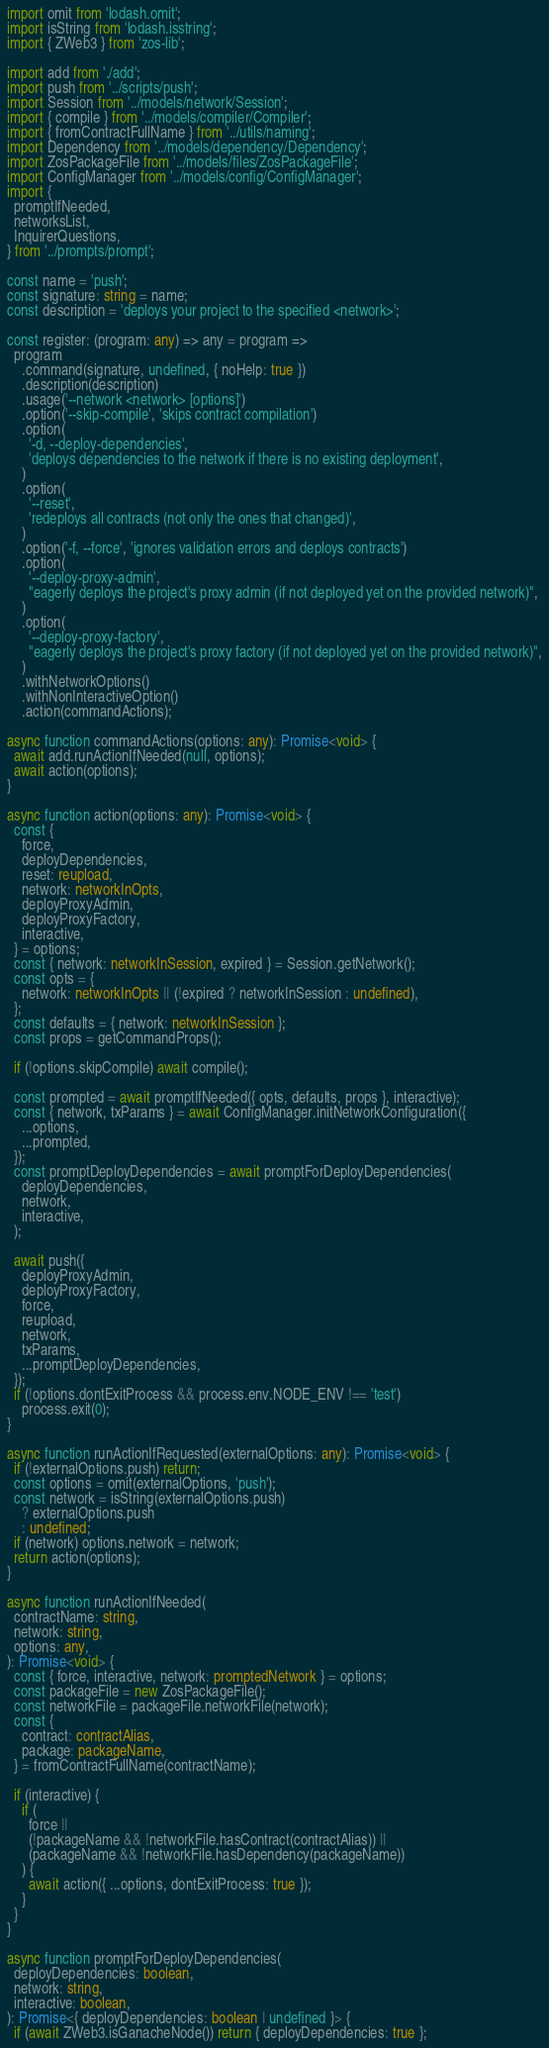Convert code to text. <code><loc_0><loc_0><loc_500><loc_500><_TypeScript_>import omit from 'lodash.omit';
import isString from 'lodash.isstring';
import { ZWeb3 } from 'zos-lib';

import add from './add';
import push from '../scripts/push';
import Session from '../models/network/Session';
import { compile } from '../models/compiler/Compiler';
import { fromContractFullName } from '../utils/naming';
import Dependency from '../models/dependency/Dependency';
import ZosPackageFile from '../models/files/ZosPackageFile';
import ConfigManager from '../models/config/ConfigManager';
import {
  promptIfNeeded,
  networksList,
  InquirerQuestions,
} from '../prompts/prompt';

const name = 'push';
const signature: string = name;
const description = 'deploys your project to the specified <network>';

const register: (program: any) => any = program =>
  program
    .command(signature, undefined, { noHelp: true })
    .description(description)
    .usage('--network <network> [options]')
    .option('--skip-compile', 'skips contract compilation')
    .option(
      '-d, --deploy-dependencies',
      'deploys dependencies to the network if there is no existing deployment',
    )
    .option(
      '--reset',
      'redeploys all contracts (not only the ones that changed)',
    )
    .option('-f, --force', 'ignores validation errors and deploys contracts')
    .option(
      '--deploy-proxy-admin',
      "eagerly deploys the project's proxy admin (if not deployed yet on the provided network)",
    )
    .option(
      '--deploy-proxy-factory',
      "eagerly deploys the project's proxy factory (if not deployed yet on the provided network)",
    )
    .withNetworkOptions()
    .withNonInteractiveOption()
    .action(commandActions);

async function commandActions(options: any): Promise<void> {
  await add.runActionIfNeeded(null, options);
  await action(options);
}

async function action(options: any): Promise<void> {
  const {
    force,
    deployDependencies,
    reset: reupload,
    network: networkInOpts,
    deployProxyAdmin,
    deployProxyFactory,
    interactive,
  } = options;
  const { network: networkInSession, expired } = Session.getNetwork();
  const opts = {
    network: networkInOpts || (!expired ? networkInSession : undefined),
  };
  const defaults = { network: networkInSession };
  const props = getCommandProps();

  if (!options.skipCompile) await compile();

  const prompted = await promptIfNeeded({ opts, defaults, props }, interactive);
  const { network, txParams } = await ConfigManager.initNetworkConfiguration({
    ...options,
    ...prompted,
  });
  const promptDeployDependencies = await promptForDeployDependencies(
    deployDependencies,
    network,
    interactive,
  );

  await push({
    deployProxyAdmin,
    deployProxyFactory,
    force,
    reupload,
    network,
    txParams,
    ...promptDeployDependencies,
  });
  if (!options.dontExitProcess && process.env.NODE_ENV !== 'test')
    process.exit(0);
}

async function runActionIfRequested(externalOptions: any): Promise<void> {
  if (!externalOptions.push) return;
  const options = omit(externalOptions, 'push');
  const network = isString(externalOptions.push)
    ? externalOptions.push
    : undefined;
  if (network) options.network = network;
  return action(options);
}

async function runActionIfNeeded(
  contractName: string,
  network: string,
  options: any,
): Promise<void> {
  const { force, interactive, network: promptedNetwork } = options;
  const packageFile = new ZosPackageFile();
  const networkFile = packageFile.networkFile(network);
  const {
    contract: contractAlias,
    package: packageName,
  } = fromContractFullName(contractName);

  if (interactive) {
    if (
      force ||
      (!packageName && !networkFile.hasContract(contractAlias)) ||
      (packageName && !networkFile.hasDependency(packageName))
    ) {
      await action({ ...options, dontExitProcess: true });
    }
  }
}

async function promptForDeployDependencies(
  deployDependencies: boolean,
  network: string,
  interactive: boolean,
): Promise<{ deployDependencies: boolean | undefined }> {
  if (await ZWeb3.isGanacheNode()) return { deployDependencies: true };</code> 